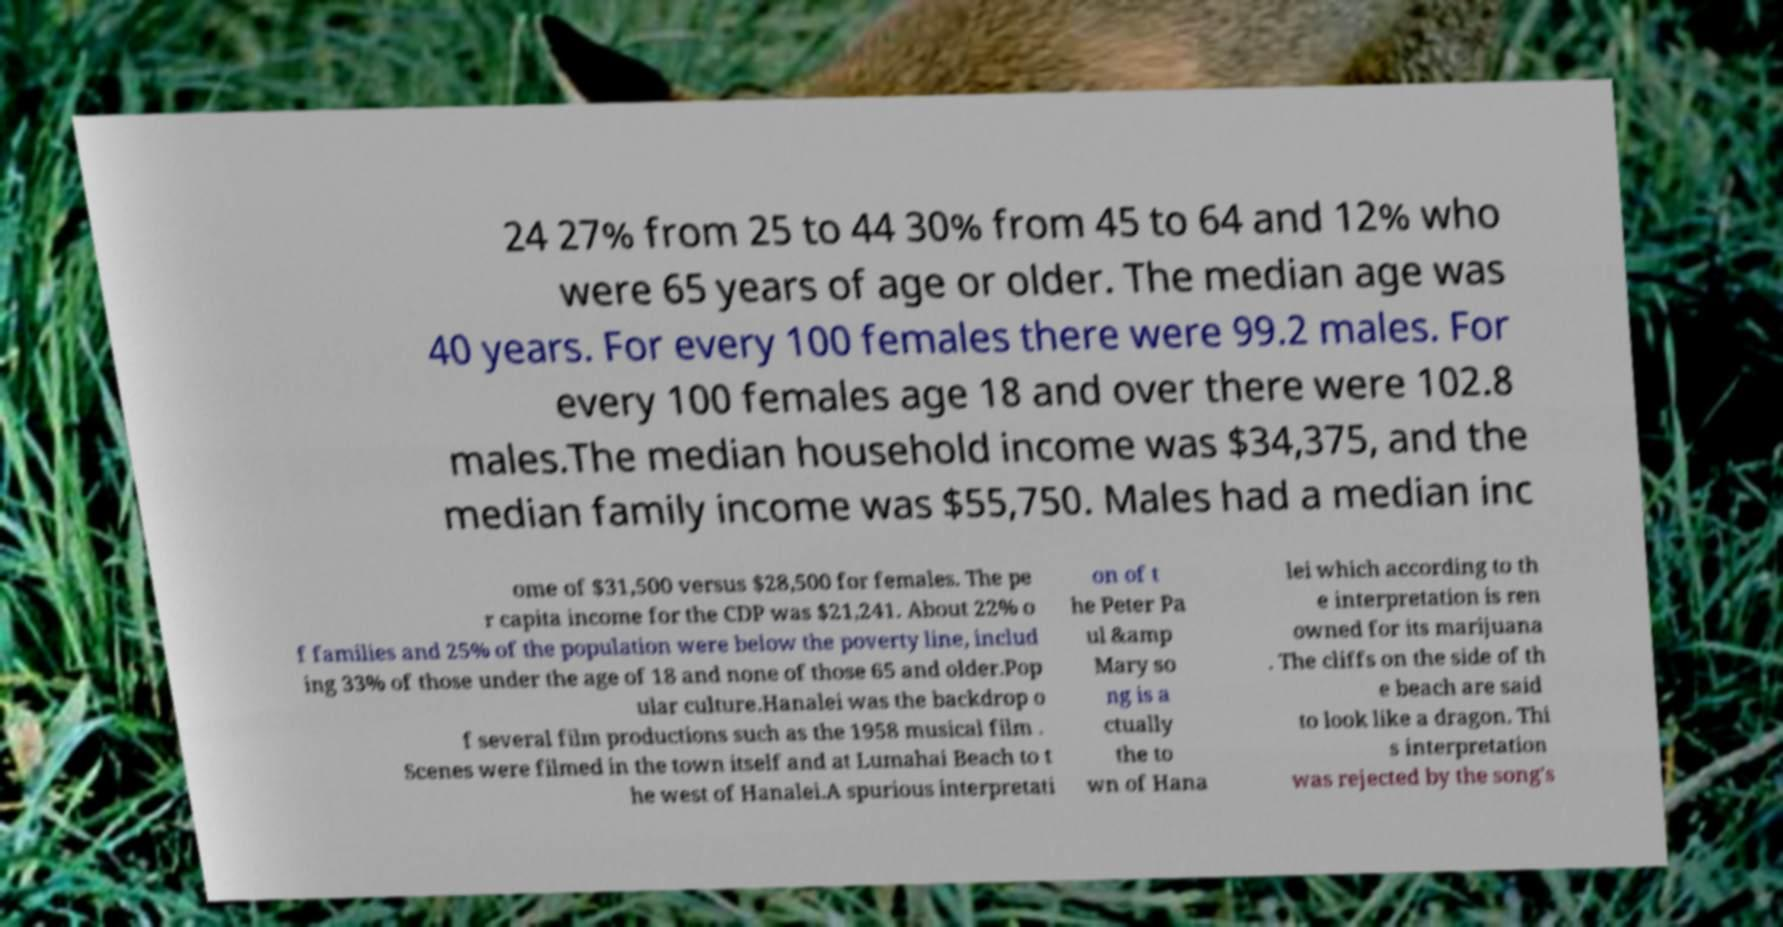Could you extract and type out the text from this image? 24 27% from 25 to 44 30% from 45 to 64 and 12% who were 65 years of age or older. The median age was 40 years. For every 100 females there were 99.2 males. For every 100 females age 18 and over there were 102.8 males.The median household income was $34,375, and the median family income was $55,750. Males had a median inc ome of $31,500 versus $28,500 for females. The pe r capita income for the CDP was $21,241. About 22% o f families and 25% of the population were below the poverty line, includ ing 33% of those under the age of 18 and none of those 65 and older.Pop ular culture.Hanalei was the backdrop o f several film productions such as the 1958 musical film . Scenes were filmed in the town itself and at Lumahai Beach to t he west of Hanalei.A spurious interpretati on of t he Peter Pa ul &amp Mary so ng is a ctually the to wn of Hana lei which according to th e interpretation is ren owned for its marijuana . The cliffs on the side of th e beach are said to look like a dragon. Thi s interpretation was rejected by the song's 